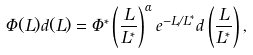Convert formula to latex. <formula><loc_0><loc_0><loc_500><loc_500>\Phi ( L ) d ( L ) = \Phi ^ { * } \left ( \frac { L } { L ^ { * } } \right ) ^ { \alpha } e ^ { - L / L ^ { * } } d \left ( \frac { L } { L ^ { * } } \right ) ,</formula> 